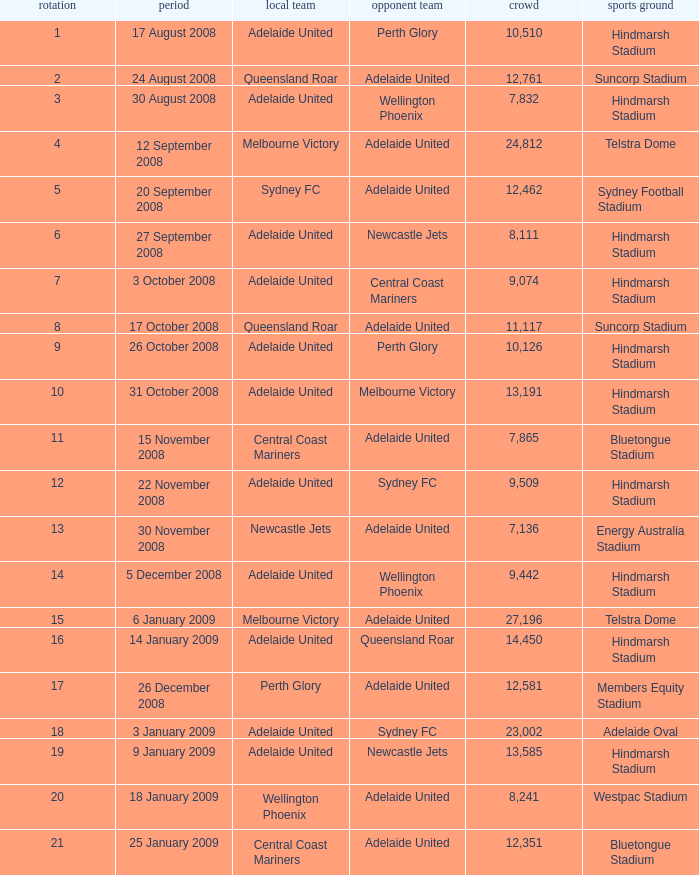What is the lowest round for the game conducted at members equity stadium with an audience of 12,581 people? None. 